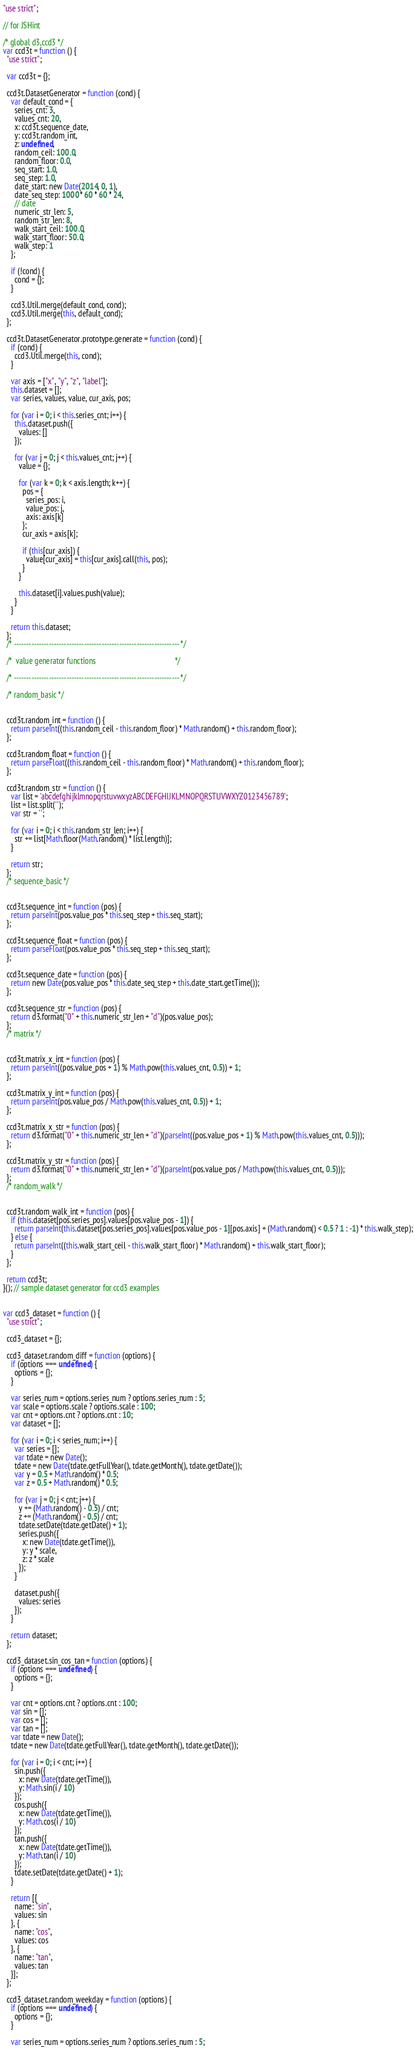<code> <loc_0><loc_0><loc_500><loc_500><_JavaScript_>"use strict";

// for JSHint

/* global d3,ccd3 */
var ccd3t = function () {
  "use strict";

  var ccd3t = {};

  ccd3t.DatasetGenerator = function (cond) {
    var default_cond = {
      series_cnt: 3,
      values_cnt: 20,
      x: ccd3t.sequence_date,
      y: ccd3t.random_int,
      z: undefined,
      random_ceil: 100.0,
      random_floor: 0.0,
      seq_start: 1.0,
      seq_step: 1.0,
      date_start: new Date(2014, 0, 1),
      date_seq_step: 1000 * 60 * 60 * 24,
      // date
      numeric_str_len: 5,
      random_str_len: 8,
      walk_start_ceil: 100.0,
      walk_start_floor: 50.0,
      walk_step: 1
    };

    if (!cond) {
      cond = {};
    }

    ccd3.Util.merge(default_cond, cond);
    ccd3.Util.merge(this, default_cond);
  };

  ccd3t.DatasetGenerator.prototype.generate = function (cond) {
    if (cond) {
      ccd3.Util.merge(this, cond);
    }

    var axis = ["x", "y", "z", "label"];
    this.dataset = [];
    var series, values, value, cur_axis, pos;

    for (var i = 0; i < this.series_cnt; i++) {
      this.dataset.push({
        values: []
      });

      for (var j = 0; j < this.values_cnt; j++) {
        value = {};

        for (var k = 0; k < axis.length; k++) {
          pos = {
            series_pos: i,
            value_pos: j,
            axis: axis[k]
          };
          cur_axis = axis[k];

          if (this[cur_axis]) {
            value[cur_axis] = this[cur_axis].call(this, pos);
          }
        }

        this.dataset[i].values.push(value);
      }
    }

    return this.dataset;
  };
  /* ------------------------------------------------------------------ */

  /*  value generator functions                                         */

  /* ------------------------------------------------------------------ */

  /* random_basic */


  ccd3t.random_int = function () {
    return parseInt((this.random_ceil - this.random_floor) * Math.random() + this.random_floor);
  };

  ccd3t.random_float = function () {
    return parseFloat((this.random_ceil - this.random_floor) * Math.random() + this.random_floor);
  };

  ccd3t.random_str = function () {
    var list = 'abcdefghijklmnopqrstuvwxyzABCDEFGHIJKLMNOPQRSTUVWXYZ0123456789';
    list = list.split('');
    var str = '';

    for (var i = 0; i < this.random_str_len; i++) {
      str += list[Math.floor(Math.random() * list.length)];
    }

    return str;
  };
  /* sequence_basic */


  ccd3t.sequence_int = function (pos) {
    return parseInt(pos.value_pos * this.seq_step + this.seq_start);
  };

  ccd3t.sequence_float = function (pos) {
    return parseFloat(pos.value_pos * this.seq_step + this.seq_start);
  };

  ccd3t.sequence_date = function (pos) {
    return new Date(pos.value_pos * this.date_seq_step + this.date_start.getTime());
  };

  ccd3t.sequence_str = function (pos) {
    return d3.format("0" + this.numeric_str_len + "d")(pos.value_pos);
  };
  /* matrix */


  ccd3t.matrix_x_int = function (pos) {
    return parseInt((pos.value_pos + 1) % Math.pow(this.values_cnt, 0.5)) + 1;
  };

  ccd3t.matrix_y_int = function (pos) {
    return parseInt(pos.value_pos / Math.pow(this.values_cnt, 0.5)) + 1;
  };

  ccd3t.matrix_x_str = function (pos) {
    return d3.format("0" + this.numeric_str_len + "d")(parseInt((pos.value_pos + 1) % Math.pow(this.values_cnt, 0.5)));
  };

  ccd3t.matrix_y_str = function (pos) {
    return d3.format("0" + this.numeric_str_len + "d")(parseInt(pos.value_pos / Math.pow(this.values_cnt, 0.5)));
  };
  /* random_walk */


  ccd3t.random_walk_int = function (pos) {
    if (this.dataset[pos.series_pos].values[pos.value_pos - 1]) {
      return parseInt(this.dataset[pos.series_pos].values[pos.value_pos - 1][pos.axis] + (Math.random() < 0.5 ? 1 : -1) * this.walk_step);
    } else {
      return parseInt((this.walk_start_ceil - this.walk_start_floor) * Math.random() + this.walk_start_floor);
    }
  };

  return ccd3t;
}(); // sample dataset generator for ccd3 examples


var ccd3_dataset = function () {
  "use strict";

  ccd3_dataset = {};

  ccd3_dataset.random_diff = function (options) {
    if (options === undefined) {
      options = {};
    }

    var series_num = options.series_num ? options.series_num : 5;
    var scale = options.scale ? options.scale : 100;
    var cnt = options.cnt ? options.cnt : 10;
    var dataset = [];

    for (var i = 0; i < series_num; i++) {
      var series = [];
      var tdate = new Date();
      tdate = new Date(tdate.getFullYear(), tdate.getMonth(), tdate.getDate());
      var y = 0.5 + Math.random() * 0.5;
      var z = 0.5 + Math.random() * 0.5;

      for (var j = 0; j < cnt; j++) {
        y += (Math.random() - 0.5) / cnt;
        z += (Math.random() - 0.5) / cnt;
        tdate.setDate(tdate.getDate() + 1);
        series.push({
          x: new Date(tdate.getTime()),
          y: y * scale,
          z: z * scale
        });
      }

      dataset.push({
        values: series
      });
    }

    return dataset;
  };

  ccd3_dataset.sin_cos_tan = function (options) {
    if (options === undefined) {
      options = {};
    }

    var cnt = options.cnt ? options.cnt : 100;
    var sin = [];
    var cos = [];
    var tan = [];
    var tdate = new Date();
    tdate = new Date(tdate.getFullYear(), tdate.getMonth(), tdate.getDate());

    for (var i = 0; i < cnt; i++) {
      sin.push({
        x: new Date(tdate.getTime()),
        y: Math.sin(i / 10)
      });
      cos.push({
        x: new Date(tdate.getTime()),
        y: Math.cos(i / 10)
      });
      tan.push({
        x: new Date(tdate.getTime()),
        y: Math.tan(i / 10)
      });
      tdate.setDate(tdate.getDate() + 1);
    }

    return [{
      name: "sin",
      values: sin
    }, {
      name: "cos",
      values: cos
    }, {
      name: "tan",
      values: tan
    }];
  };

  ccd3_dataset.random_weekday = function (options) {
    if (options === undefined) {
      options = {};
    }

    var series_num = options.series_num ? options.series_num : 5;</code> 